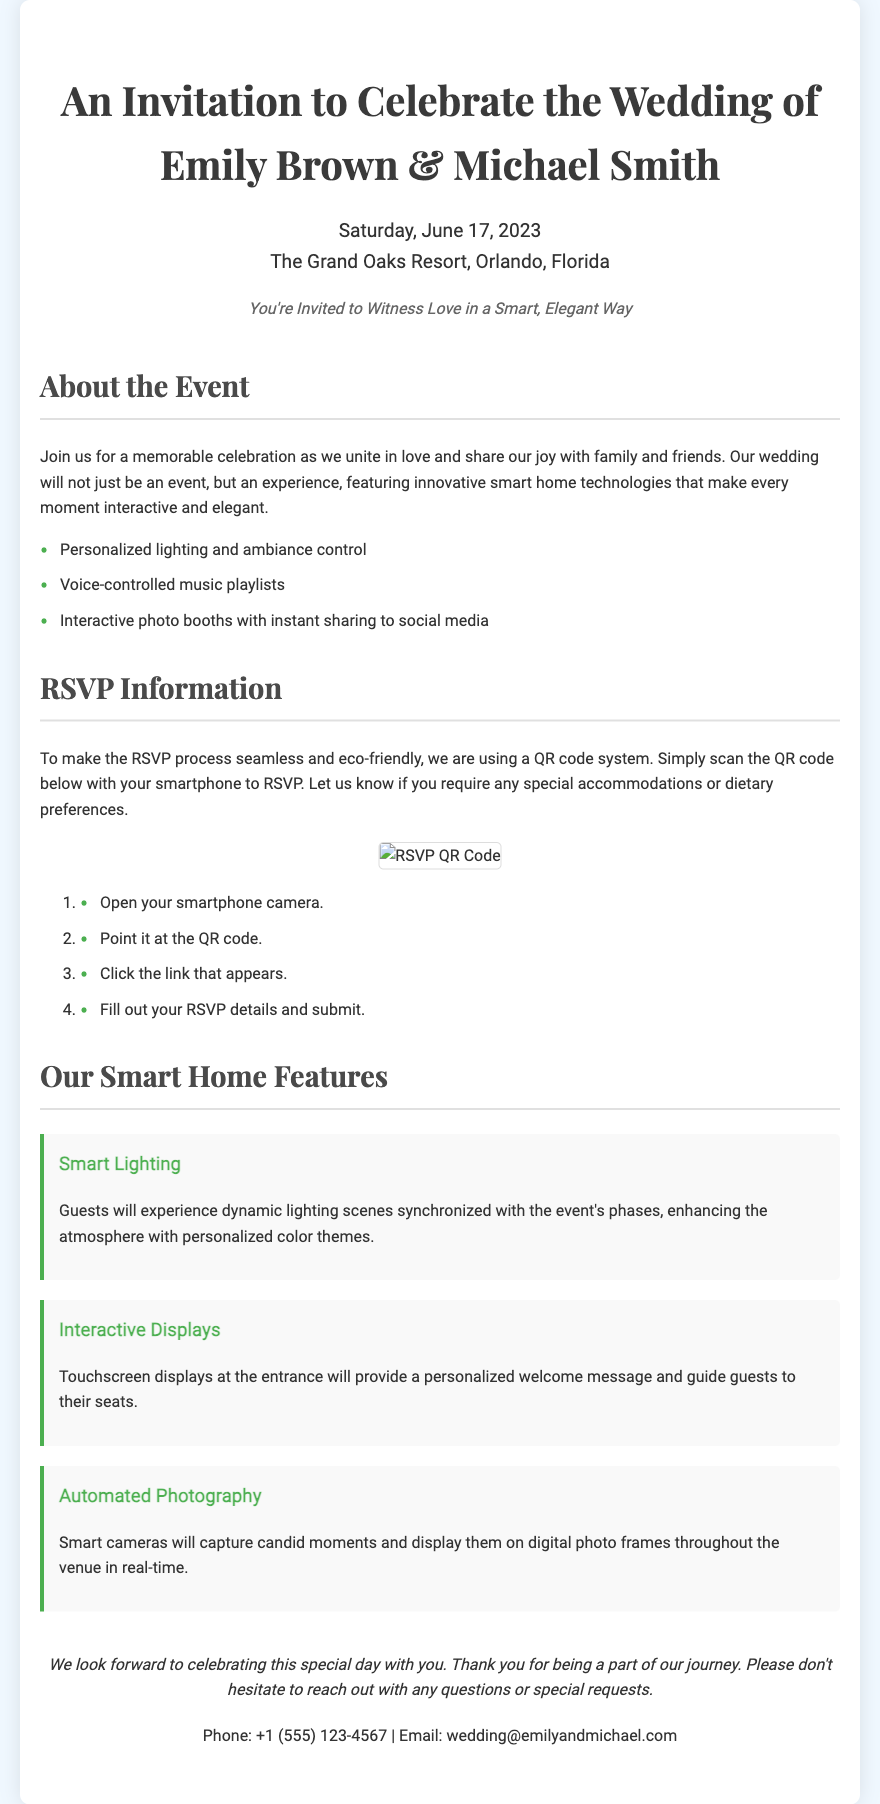What is the wedding date? The wedding date is specifically mentioned in the document as Saturday, June 17, 2023.
Answer: Saturday, June 17, 2023 Where is the wedding taking place? The location of the wedding is stated in the document as The Grand Oaks Resort, Orlando, Florida.
Answer: The Grand Oaks Resort, Orlando, Florida What technology is used for RSVPs? The document mentions a QR code system for RSVPs.
Answer: QR code What is one feature of the smart home wedding experience? The features listed include personalized lighting and ambiance control, which highlights the innovative setup at the wedding.
Answer: Personalized lighting and ambiance control How can guests RSVP according to the instructions? The document provides step-by-step instructions to RSVP by scanning the QR code, which is a key interactive element.
Answer: By scanning the QR code What kind of greeting will guests find upon entering? Touchscreen displays will provide a personalized welcome message, enhancing the interactive experience at the wedding.
Answer: Personalized welcome message What is the primary color theme reflected in the text? The document shows an elegant theme with a color scheme including shades of green, as seen in various sections such as bullet points and headings.
Answer: Green What type of event is described in this document? This document specifically describes a wedding event focused on love and innovative technology.
Answer: Wedding 